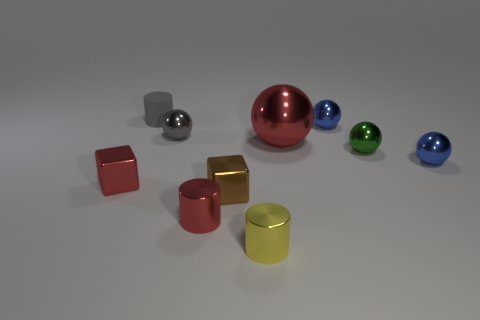Subtract all gray balls. How many balls are left? 4 Subtract all small gray shiny spheres. How many spheres are left? 4 Subtract all brown spheres. Subtract all gray blocks. How many spheres are left? 5 Subtract all cylinders. How many objects are left? 7 Add 2 small blue shiny spheres. How many small blue shiny spheres exist? 4 Subtract 0 purple cylinders. How many objects are left? 10 Subtract all large purple rubber spheres. Subtract all blue things. How many objects are left? 8 Add 5 small green shiny objects. How many small green shiny objects are left? 6 